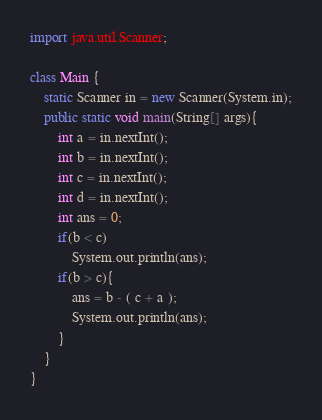<code> <loc_0><loc_0><loc_500><loc_500><_Java_>import java.util.Scanner;

class Main {
    static Scanner in = new Scanner(System.in);
    public static void main(String[] args){
        int a = in.nextInt();
        int b = in.nextInt();
        int c = in.nextInt();
        int d = in.nextInt();
        int ans = 0;
        if(b < c)
            System.out.println(ans);
        if(b > c){
            ans = b - ( c + a );
            System.out.println(ans);
        }
    }
}
</code> 